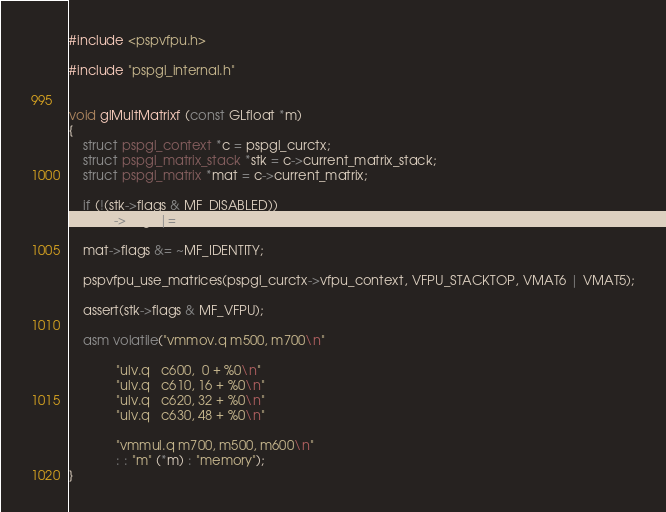Convert code to text. <code><loc_0><loc_0><loc_500><loc_500><_C_>#include <pspvfpu.h>

#include "pspgl_internal.h"


void glMultMatrixf (const GLfloat *m)
{
	struct pspgl_context *c = pspgl_curctx;
	struct pspgl_matrix_stack *stk = c->current_matrix_stack;
	struct pspgl_matrix *mat = c->current_matrix;

	if (!(stk->flags & MF_DISABLED))
		stk->flags |= MF_DIRTY;

	mat->flags &= ~MF_IDENTITY;

	pspvfpu_use_matrices(pspgl_curctx->vfpu_context, VFPU_STACKTOP, VMAT6 | VMAT5);

	assert(stk->flags & MF_VFPU);

	asm volatile("vmmov.q	m500, m700\n"

		     "ulv.q	c600,  0 + %0\n"
		     "ulv.q	c610, 16 + %0\n"
		     "ulv.q	c620, 32 + %0\n"
		     "ulv.q	c630, 48 + %0\n"

		     "vmmul.q	m700, m500, m600\n"
		     : : "m" (*m) : "memory");
}

</code> 